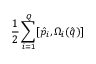Convert formula to latex. <formula><loc_0><loc_0><loc_500><loc_500>\frac { 1 } { 2 } \sum _ { i = 1 } ^ { Q } [ \hat { p } _ { i } , \Omega _ { i } ( \hat { q } ) ]</formula> 